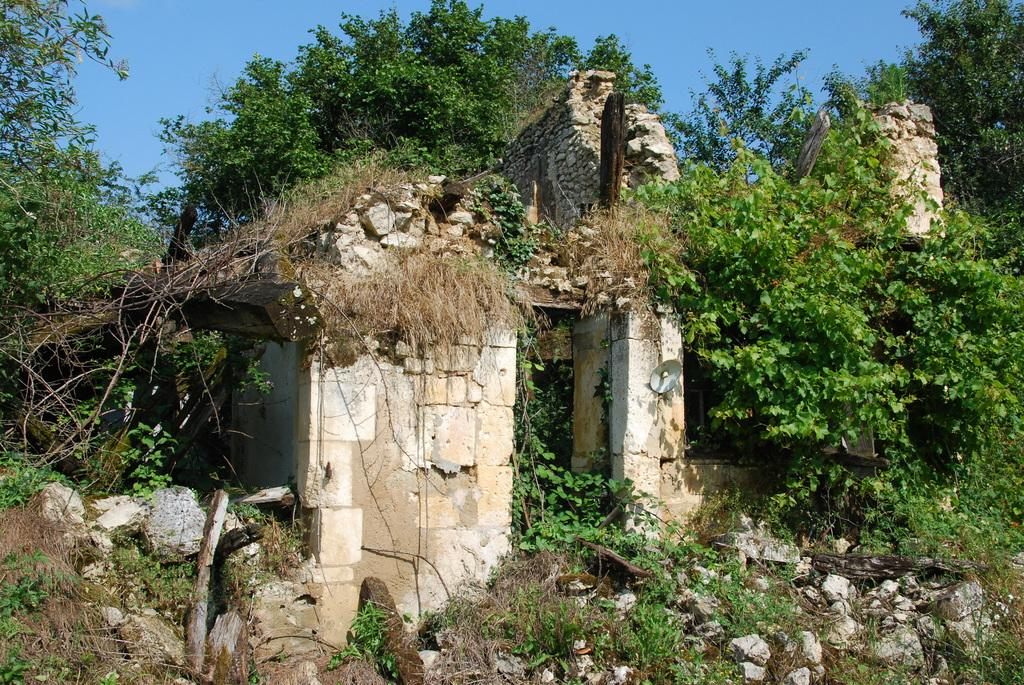What structure can be seen on the right side of the image? There is a pillar on the right side of the image. What is the condition of the wall in the image? There is a broken wall in the image. What type of vegetation is present in the image? There is grass, plants, and trees in the image. What other natural elements can be seen in the image? There are rocks in the image. What is the condition of the sky in the image? The sky is clear in the image. What month is depicted in the image? The image does not depict a specific month; it only shows a clear sky, which can be seen in various months. Can you see a ball being played with in the image? There is no ball present in the image. 